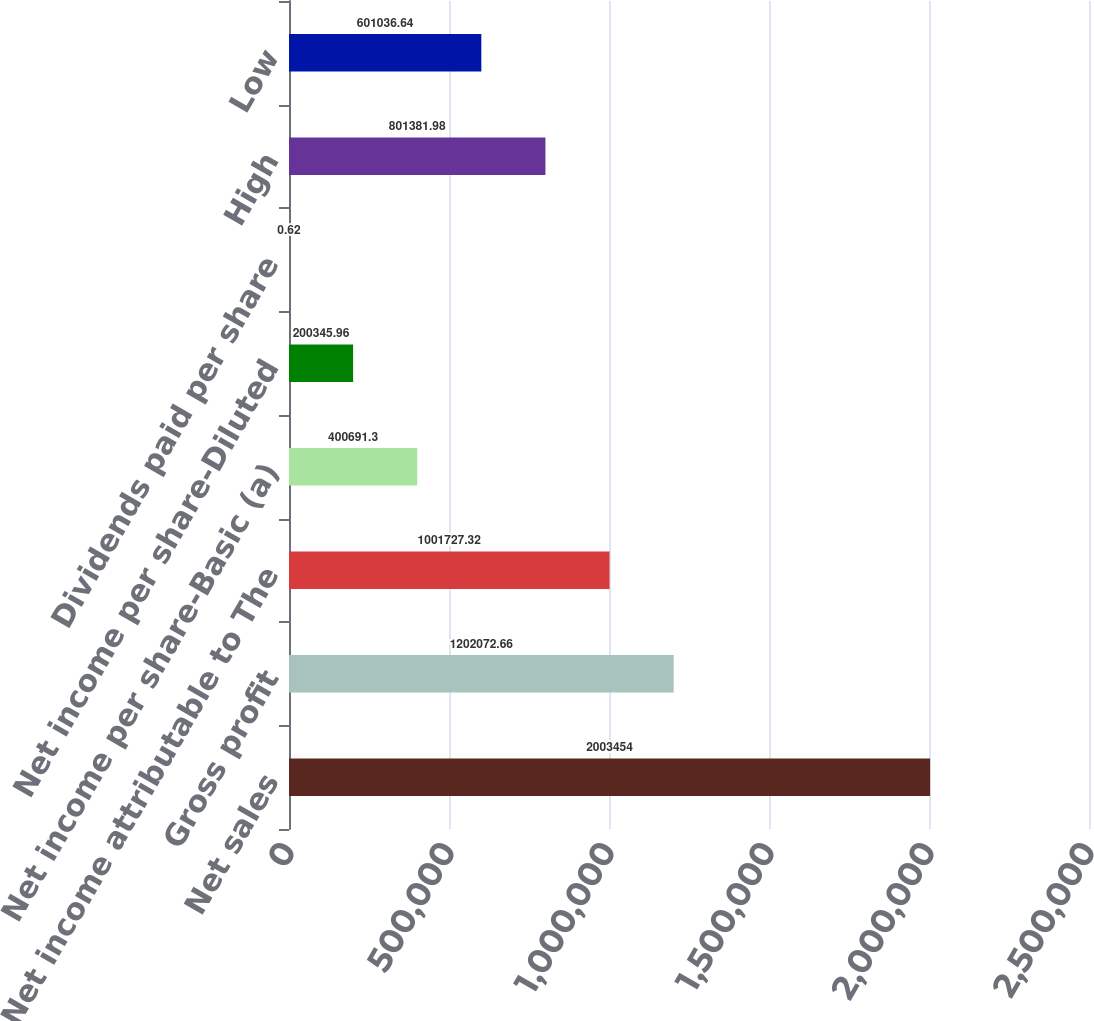Convert chart to OTSL. <chart><loc_0><loc_0><loc_500><loc_500><bar_chart><fcel>Net sales<fcel>Gross profit<fcel>Net income attributable to The<fcel>Net income per share-Basic (a)<fcel>Net income per share-Diluted<fcel>Dividends paid per share<fcel>High<fcel>Low<nl><fcel>2.00345e+06<fcel>1.20207e+06<fcel>1.00173e+06<fcel>400691<fcel>200346<fcel>0.62<fcel>801382<fcel>601037<nl></chart> 